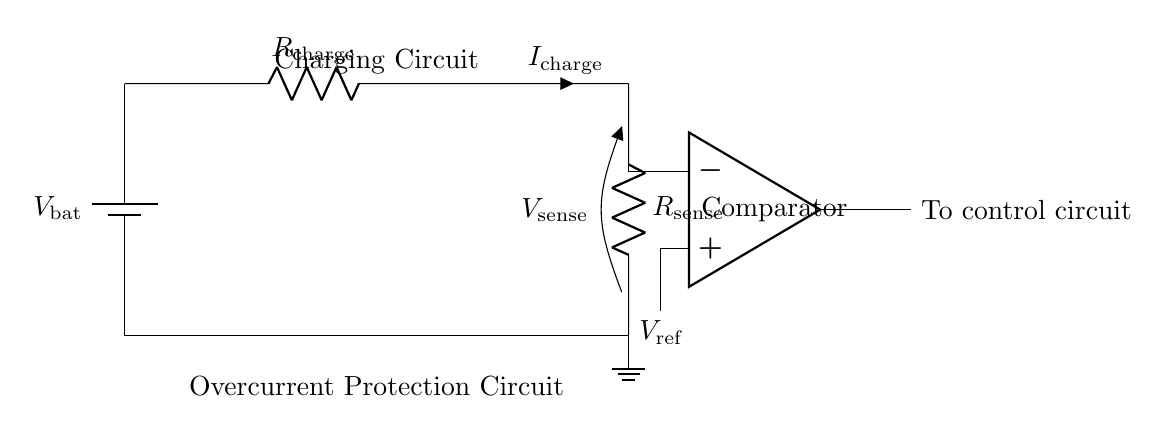What is the type of the battery in this circuit? The battery symbol is labeled as V_bat, indicating it is a voltage source, typically representing a lithium-ion battery in this context.
Answer: lithium-ion What component is used to sense the charging current? The current-sense resistor is identified by the label R_sense, which is specifically designed to measure the current by developing a voltage drop across it.
Answer: R_sense What voltage is connected to the non-inverting terminal of the comparator? The non-inverting terminal of the comparator is connected to V_ref, which is denoted in the diagram, showing that this is the reference voltage for comparison.
Answer: V_ref What happens if the current exceeds the threshold? If the current exceeds the threshold, the comparator will activate the control circuit as indicated by the output connection, leading to protective action against overcurrent.
Answer: Trigger protection What is the purpose of the comparator in this circuit? The comparator compares the voltage from the current-sense resistor to the reference voltage, determining if the current exceeds a preset limit, thus enabling the overcurrent protection mechanism.
Answer: Overcurrent protection What is the label for the charging circuit component? The charging circuit component in this diagram is labeled as R_charge, indicating it is a resistor associated with the charging process of the lithium-ion battery.
Answer: R_charge 